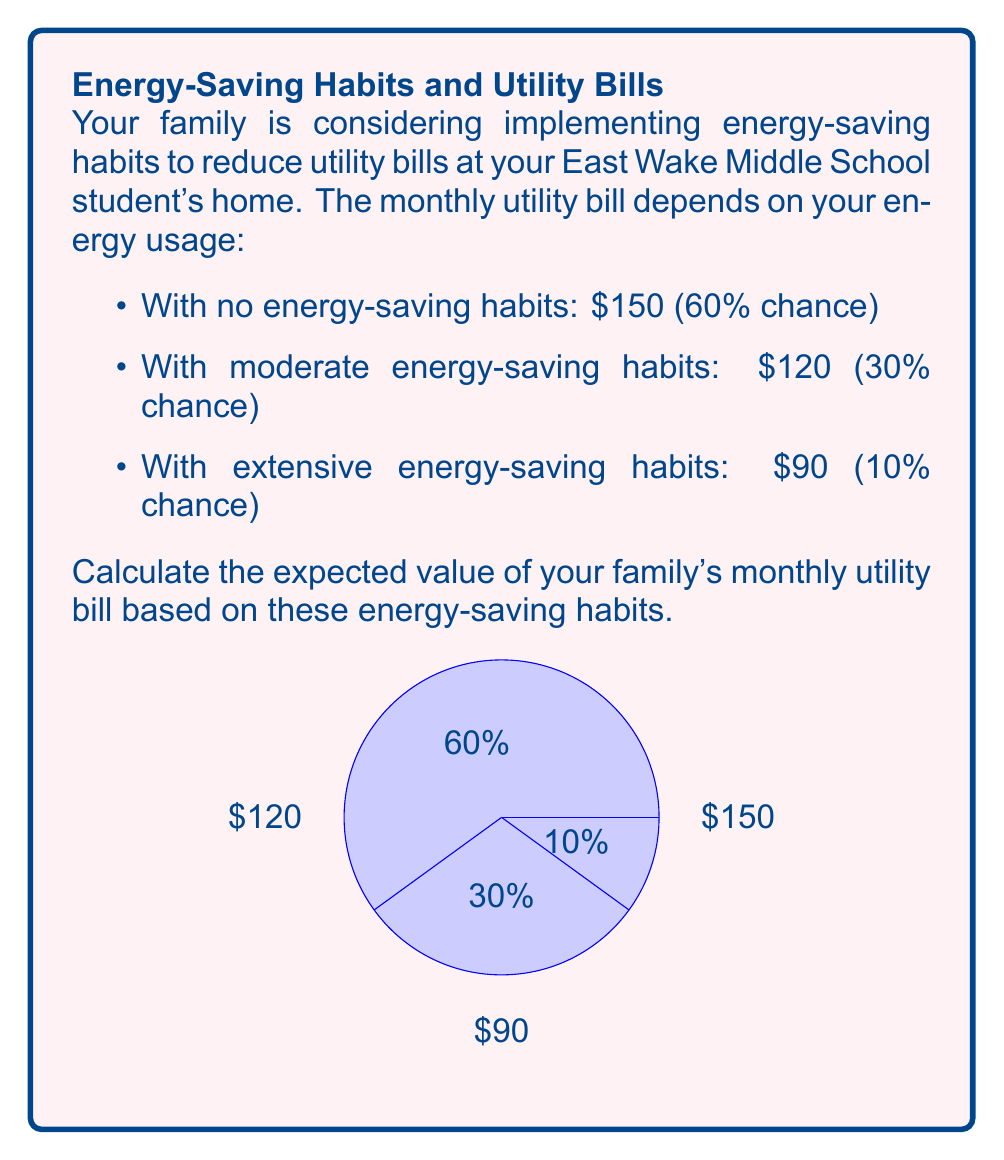Can you answer this question? To calculate the expected value, we need to multiply each possible outcome by its probability and then sum these products. Let's break it down step-by-step:

1) For no energy-saving habits:
   Probability = 60% = 0.60
   Bill = $150
   $$ 0.60 \times \$150 = \$90 $$

2) For moderate energy-saving habits:
   Probability = 30% = 0.30
   Bill = $120
   $$ 0.30 \times \$120 = \$36 $$

3) For extensive energy-saving habits:
   Probability = 10% = 0.10
   Bill = $90
   $$ 0.10 \times \$90 = \$9 $$

4) Now, we sum these products to get the expected value:
   $$ E(\text{Bill}) = \$90 + \$36 + \$9 = \$135 $$

Therefore, the expected value of the family's monthly utility bill is $135.
Answer: $135 